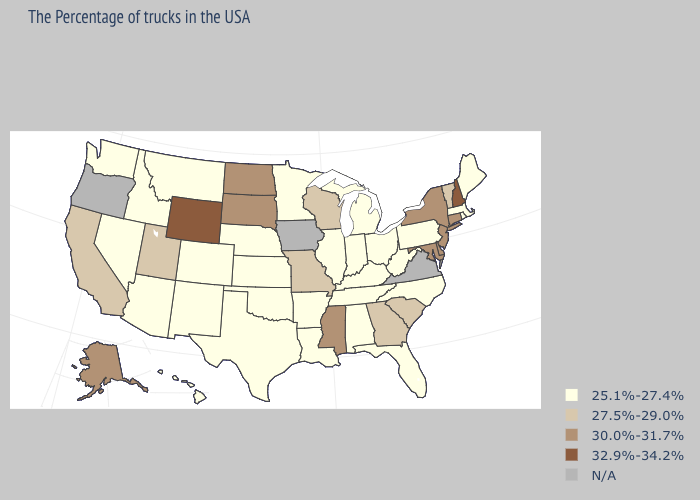Does New Hampshire have the highest value in the USA?
Quick response, please. Yes. Name the states that have a value in the range N/A?
Concise answer only. Virginia, Iowa, Oregon. What is the lowest value in the West?
Give a very brief answer. 25.1%-27.4%. Does Louisiana have the highest value in the USA?
Keep it brief. No. Name the states that have a value in the range N/A?
Keep it brief. Virginia, Iowa, Oregon. Does South Carolina have the highest value in the USA?
Be succinct. No. Which states hav the highest value in the South?
Keep it brief. Delaware, Maryland, Mississippi. What is the lowest value in states that border Indiana?
Be succinct. 25.1%-27.4%. What is the value of West Virginia?
Answer briefly. 25.1%-27.4%. Name the states that have a value in the range N/A?
Write a very short answer. Virginia, Iowa, Oregon. What is the value of California?
Be succinct. 27.5%-29.0%. Does New Hampshire have the highest value in the USA?
Be succinct. Yes. What is the highest value in the USA?
Answer briefly. 32.9%-34.2%. 